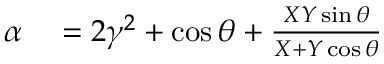<formula> <loc_0><loc_0><loc_500><loc_500>\begin{array} { r l } { \alpha } & = 2 \gamma ^ { 2 } + \cos \theta + \frac { X Y \sin \theta } { X + Y \cos \theta } } \end{array}</formula> 